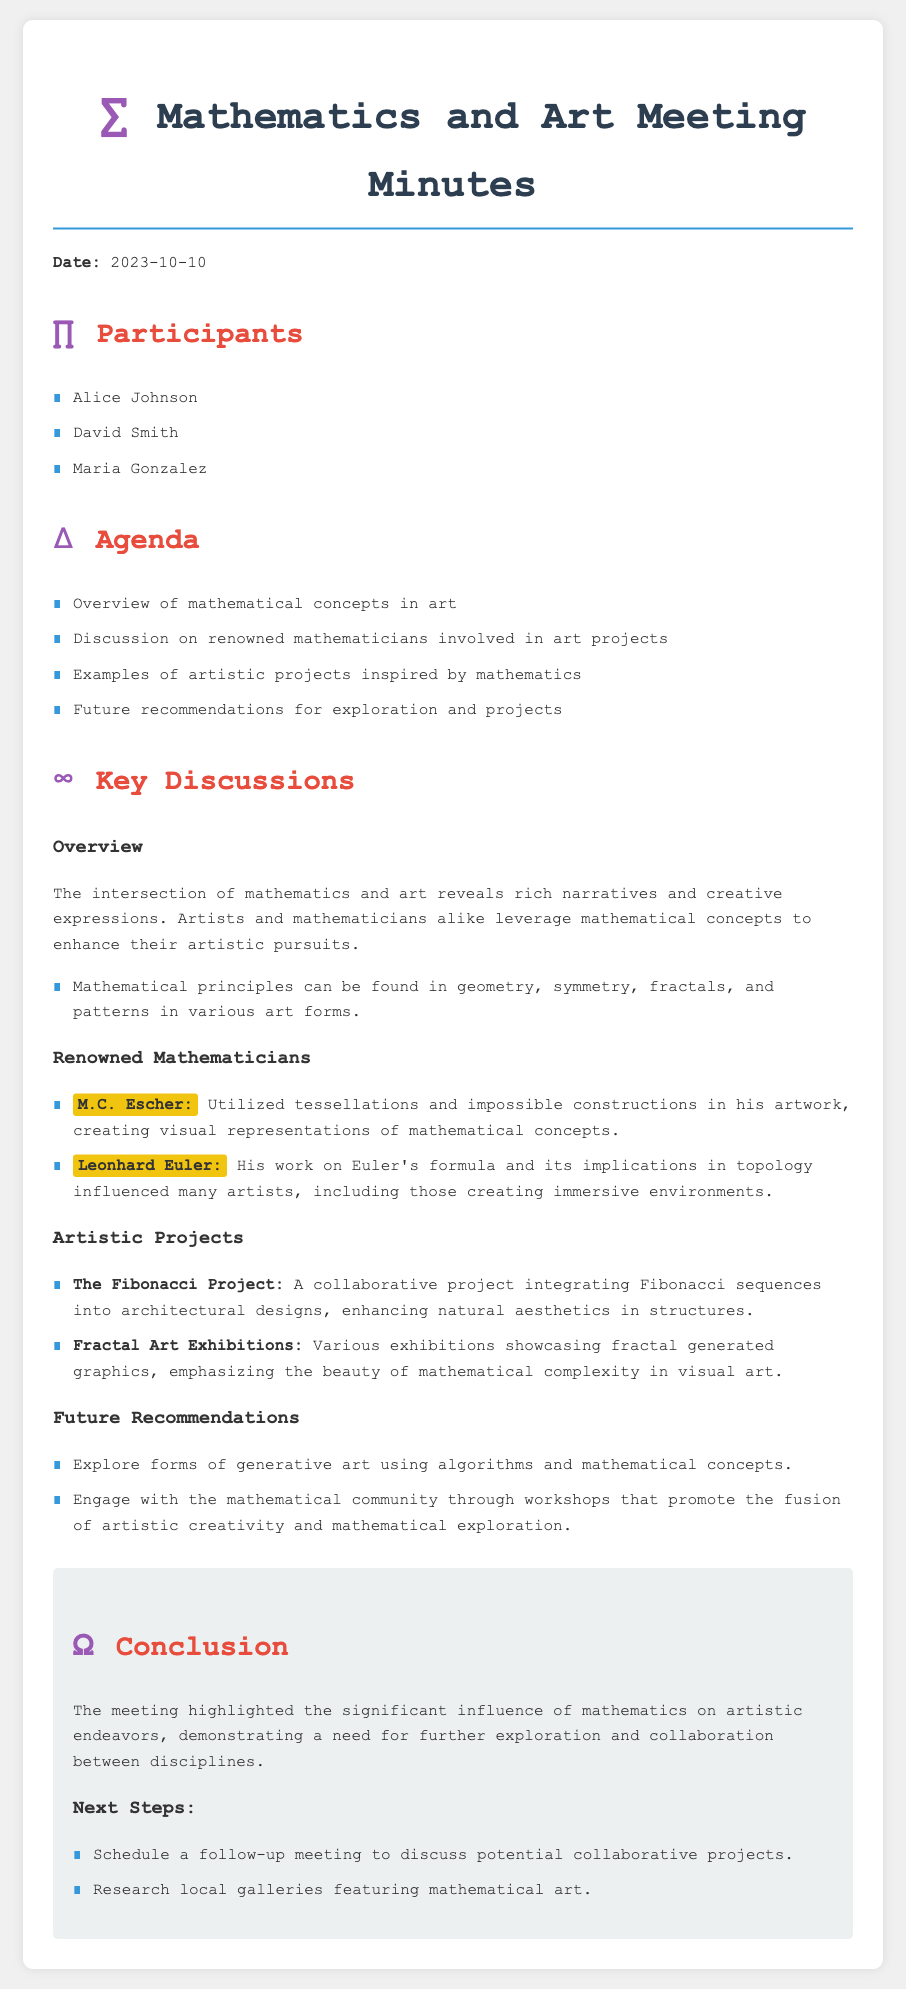What is the date of the meeting? The date of the meeting is explicitly stated in the introduction section of the minutes.
Answer: 2023-10-10 Who is one of the renowned mathematicians mentioned in the document? The document lists several renowned mathematicians under the "Renowned Mathematicians" section, highlighting their contributions.
Answer: M.C. Escher What is one example of an artistic project mentioned? The document provides specific examples of artistic projects inspired by mathematics in the "Artistic Projects" section.
Answer: The Fibonacci Project What was one of the main agendas discussed in the meeting? The agenda items listed cover various aspects of the relationship between mathematics and art as stated in the document.
Answer: Overview of mathematical concepts in art What is the main conclusion summarized in the meeting minutes? The conclusion section provides an overview of the key outcome and suggests the need for further exploration.
Answer: The significant influence of mathematics on artistic endeavors 